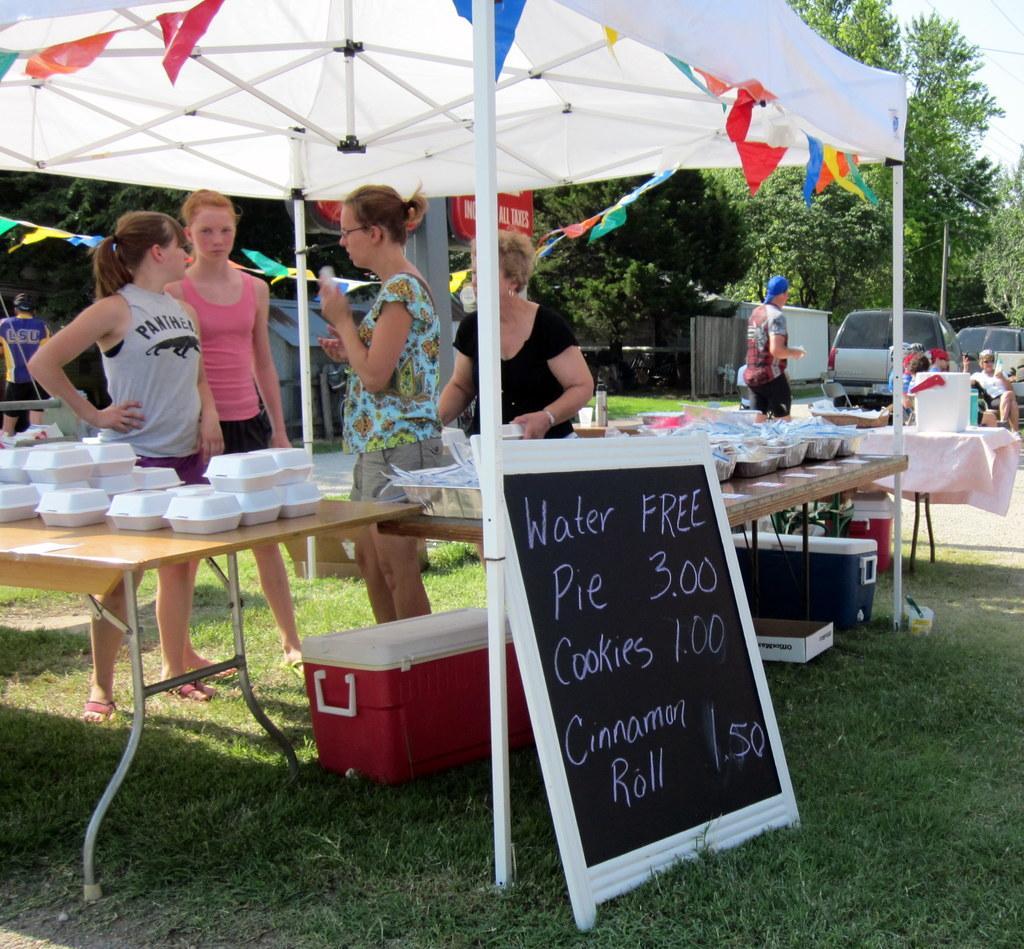How would you summarize this image in a sentence or two? There are 4 women standing beside a table under a tent,behind them there are few people,trees,vehicles,boxes. On the right there is a board. 